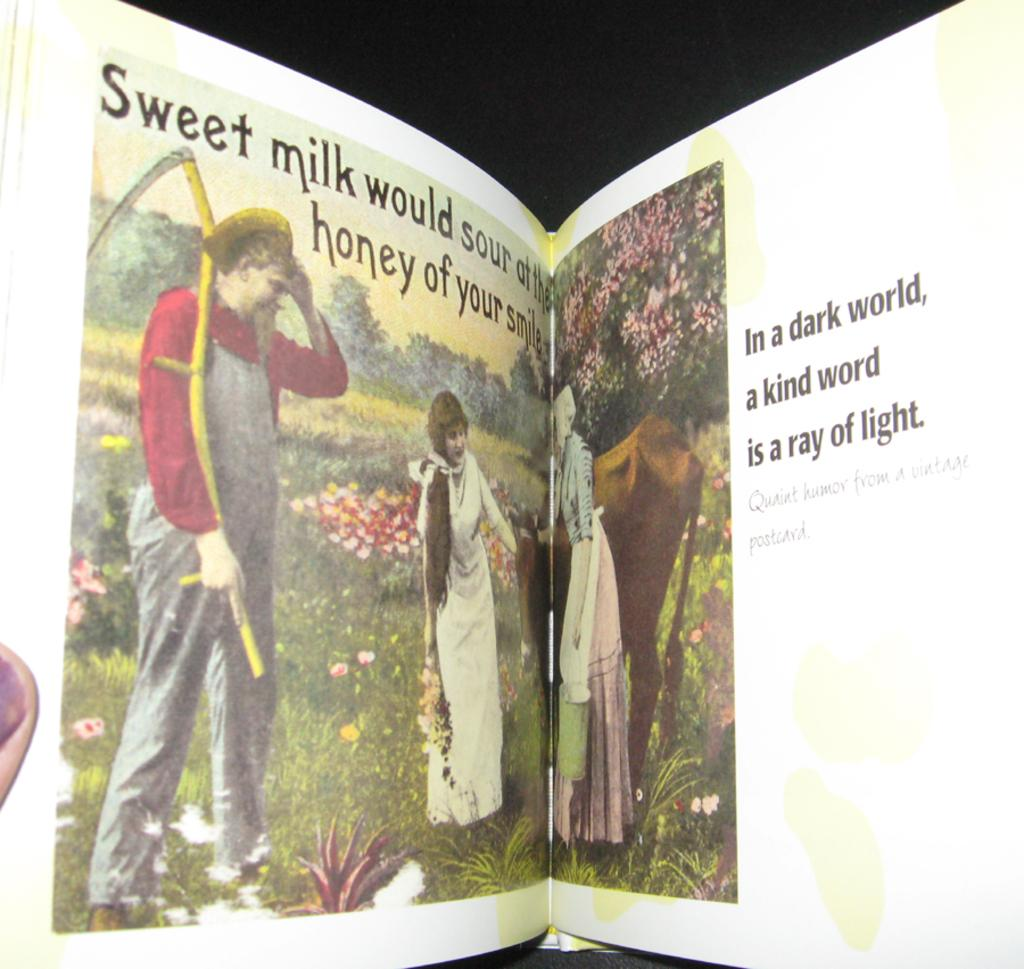<image>
Give a short and clear explanation of the subsequent image. A book is showing people a meadow and the text sweet milk would sour at the honey of your smile. 